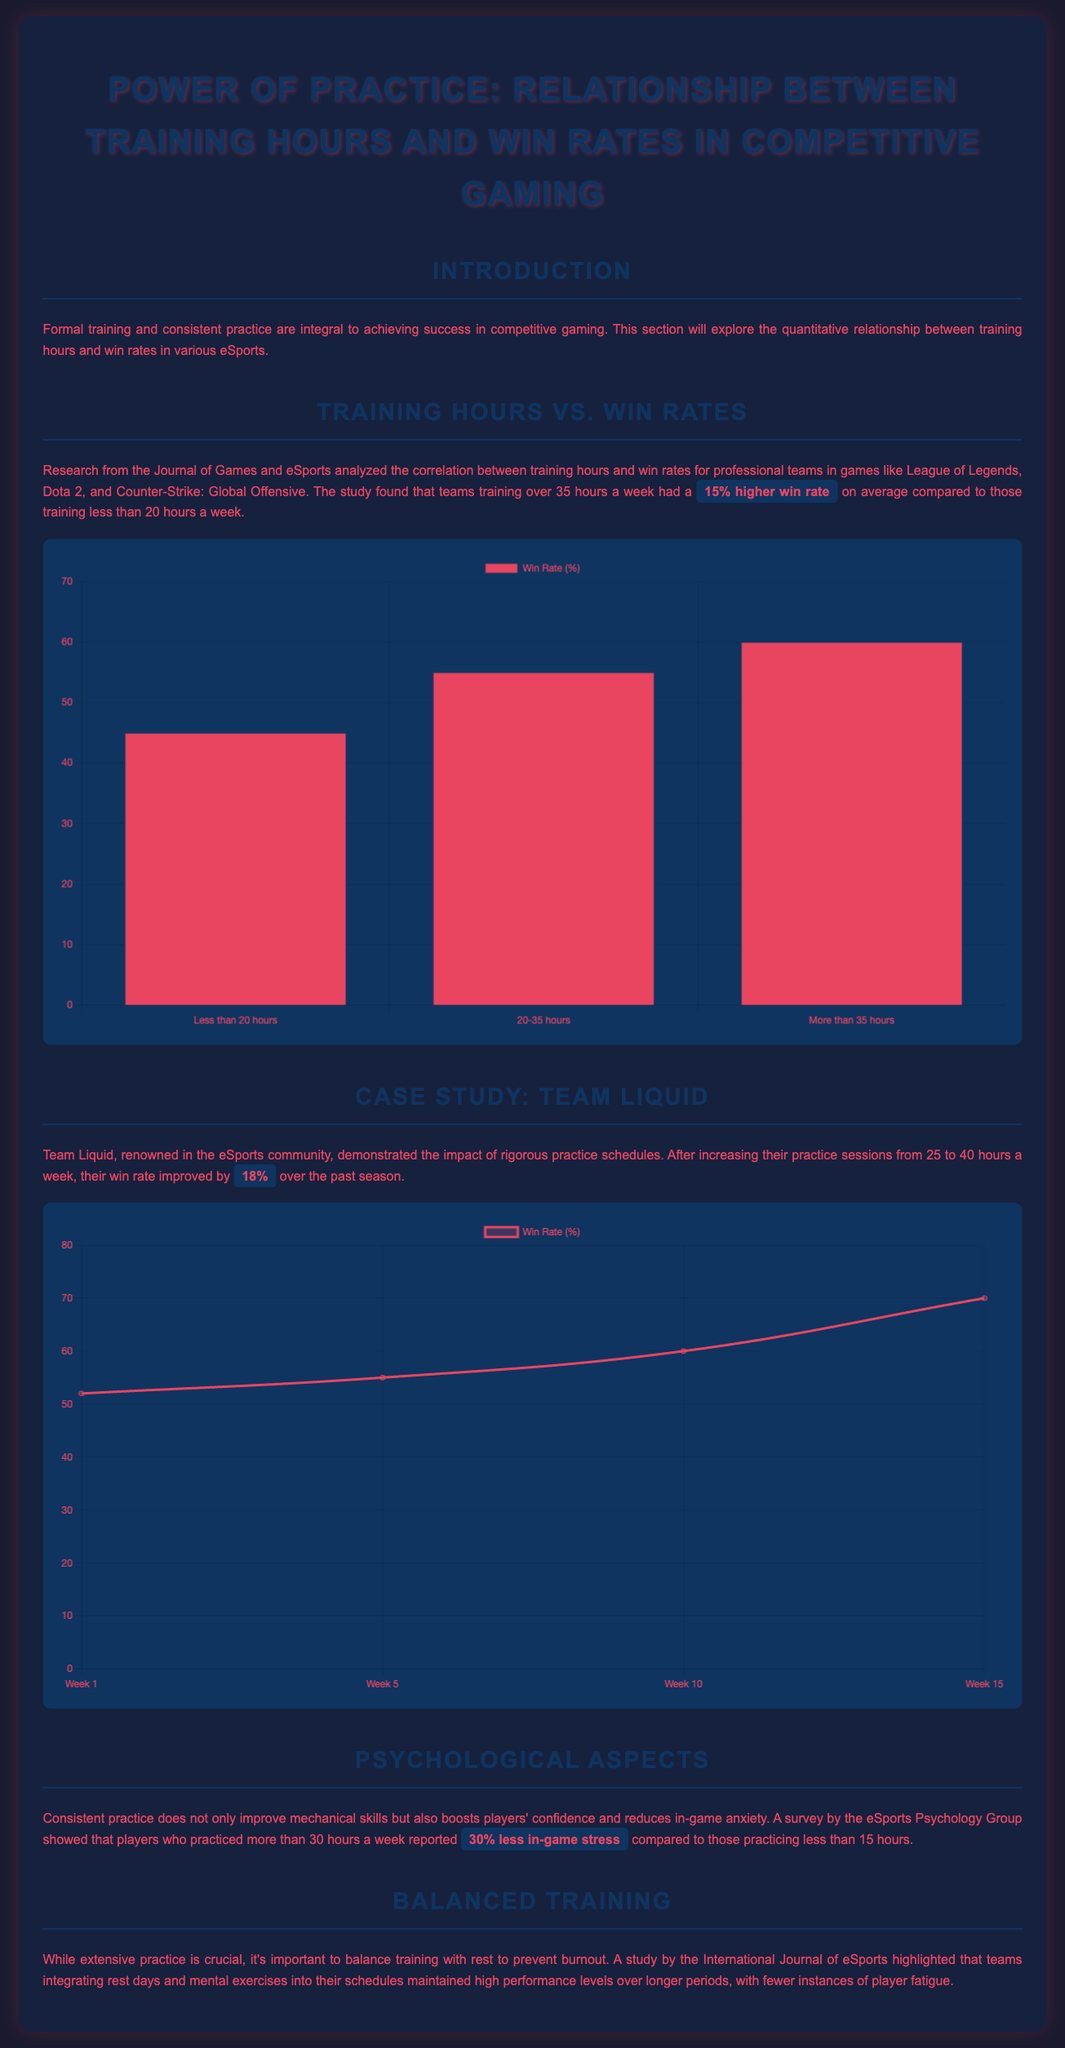what is the average win rate increase for teams training over 35 hours? The document states that teams training over 35 hours a week had a 15% higher win rate on average compared to those training less than 20 hours a week.
Answer: 15% what was Team Liquid's win rate after increasing practice hours? The document mentions that Team Liquid's win rate improved by 18% after increasing their practice sessions from 25 to 40 hours a week.
Answer: 18% how many hours a week did Team Liquid practice after the increase? The document states that Team Liquid increased their practice sessions to 40 hours a week.
Answer: 40 hours what percentage less in-game stress did players practicing over 30 hours report? According to the document, players who practiced more than 30 hours a week reported 30% less in-game stress compared to those practicing less than 15 hours.
Answer: 30% what is the maximum win rate percentage shown in the Training Hours vs. Win Rates chart? The chart in the document indicates that the maximum win rate percentage shown is 60%.
Answer: 60% which games were included in the research from the Journal of Games and eSports? The document mentions that the research analyzed games like League of Legends, Dota 2, and Counter-Strike: Global Offensive.
Answer: League of Legends, Dota 2, Counter-Strike: Global Offensive what type of chart is used to represent Team Liquid's win rate data? The document specifies that a line chart is used to represent Team Liquid's win rate data.
Answer: Line chart how many weeks are represented in the Team Liquid case study chart? The document states that the Team Liquid case study chart represents a total of 4 weeks.
Answer: 4 weeks what is the win rate percentage for teams training less than 20 hours a week? The document reveals that the win rate percentage for teams training less than 20 hours a week is 45%.
Answer: 45% 